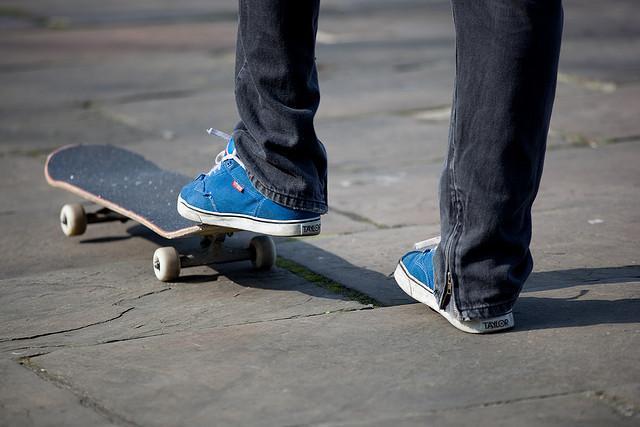How many feet are on the skateboard?
Give a very brief answer. 1. 